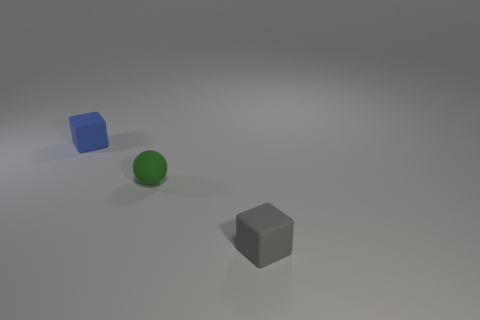Add 2 cyan matte spheres. How many objects exist? 5 Subtract all cubes. How many objects are left? 1 Subtract 0 yellow blocks. How many objects are left? 3 Subtract all large cyan metallic cylinders. Subtract all tiny green matte spheres. How many objects are left? 2 Add 2 small green objects. How many small green objects are left? 3 Add 1 small matte balls. How many small matte balls exist? 2 